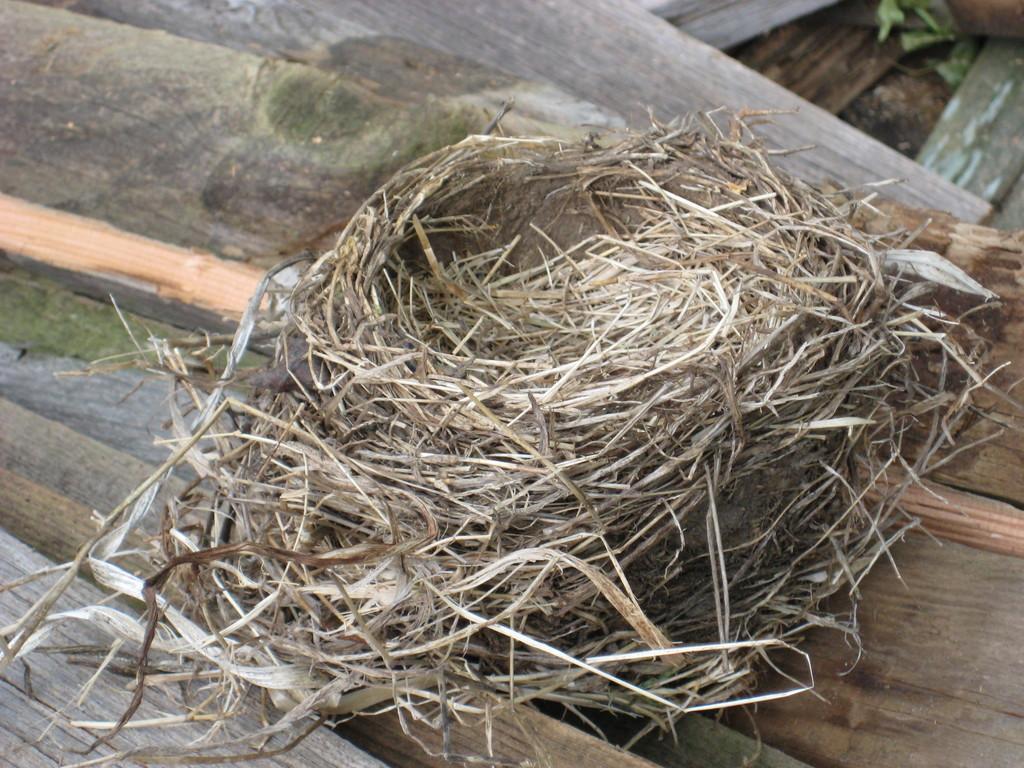How would you summarize this image in a sentence or two? In the image we can see a nest and there are wooden sheets. 